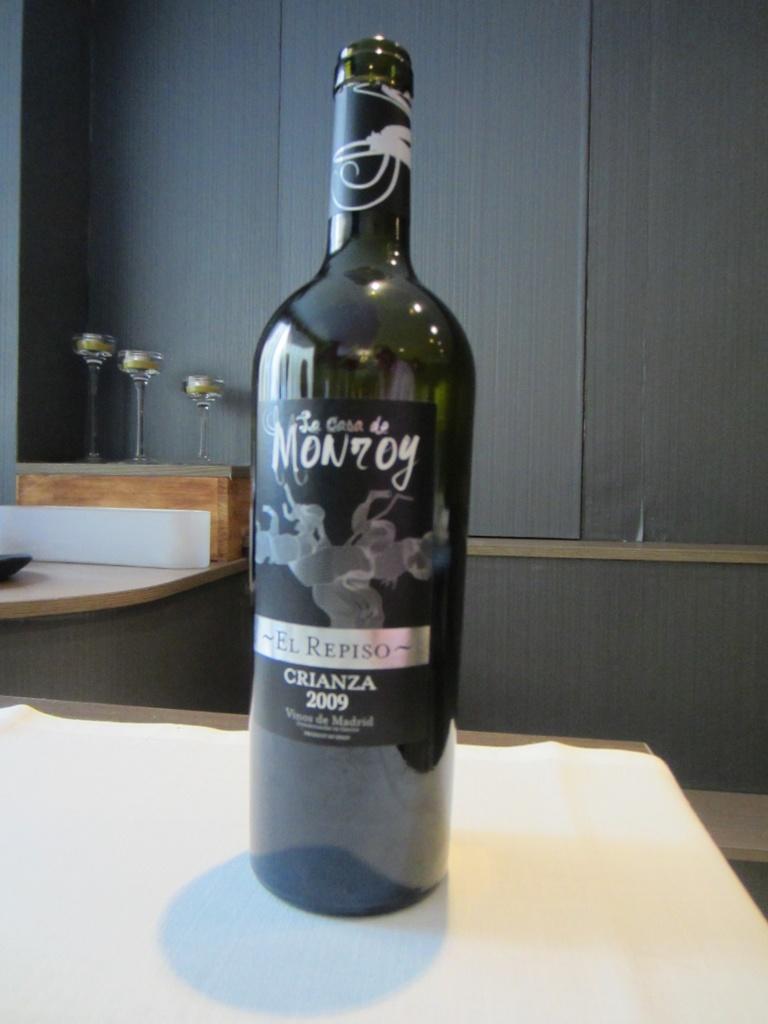What year was this bottle of wine made?
Provide a succinct answer. 2009. What type of alcohol is this?
Your response must be concise. Crianza. 